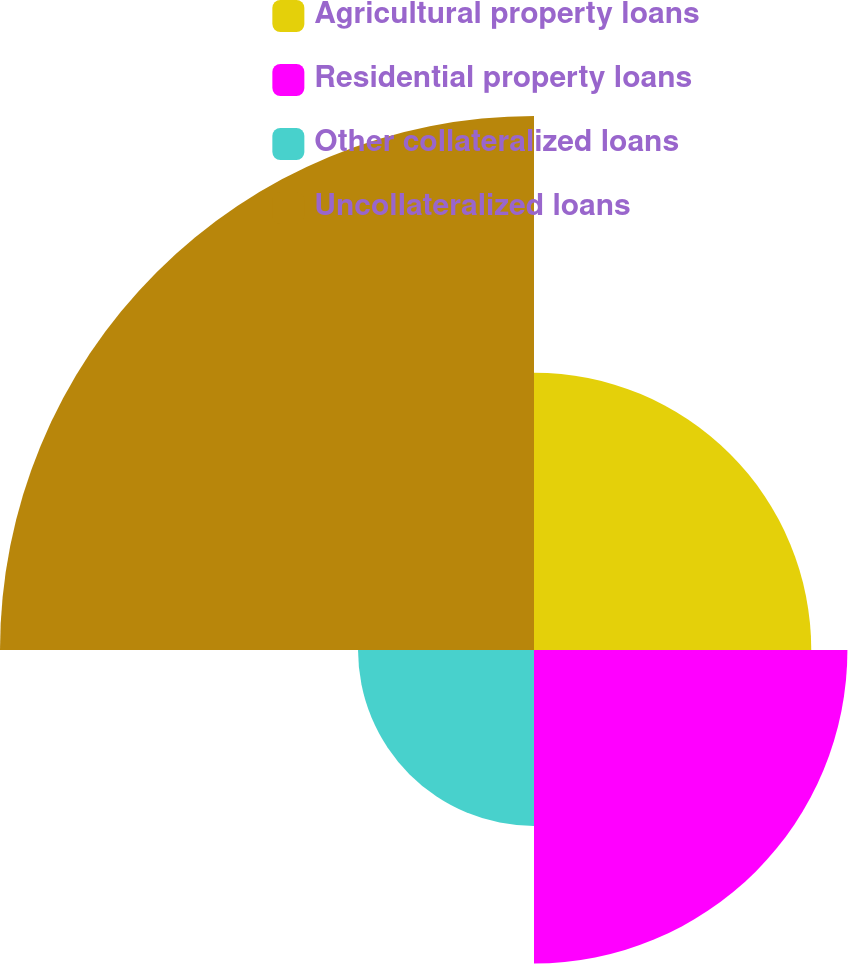<chart> <loc_0><loc_0><loc_500><loc_500><pie_chart><fcel>Agricultural property loans<fcel>Residential property loans<fcel>Other collateralized loans<fcel>Uncollateralized loans<nl><fcel>21.32%<fcel>24.1%<fcel>13.53%<fcel>41.06%<nl></chart> 